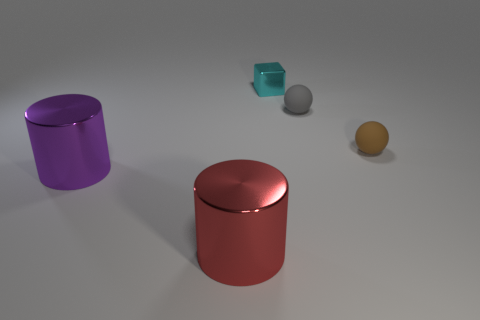Add 2 small metallic blocks. How many objects exist? 7 Subtract all cubes. How many objects are left? 4 Subtract all large gray metal things. Subtract all cylinders. How many objects are left? 3 Add 5 tiny blocks. How many tiny blocks are left? 6 Add 4 gray objects. How many gray objects exist? 5 Subtract 0 cyan cylinders. How many objects are left? 5 